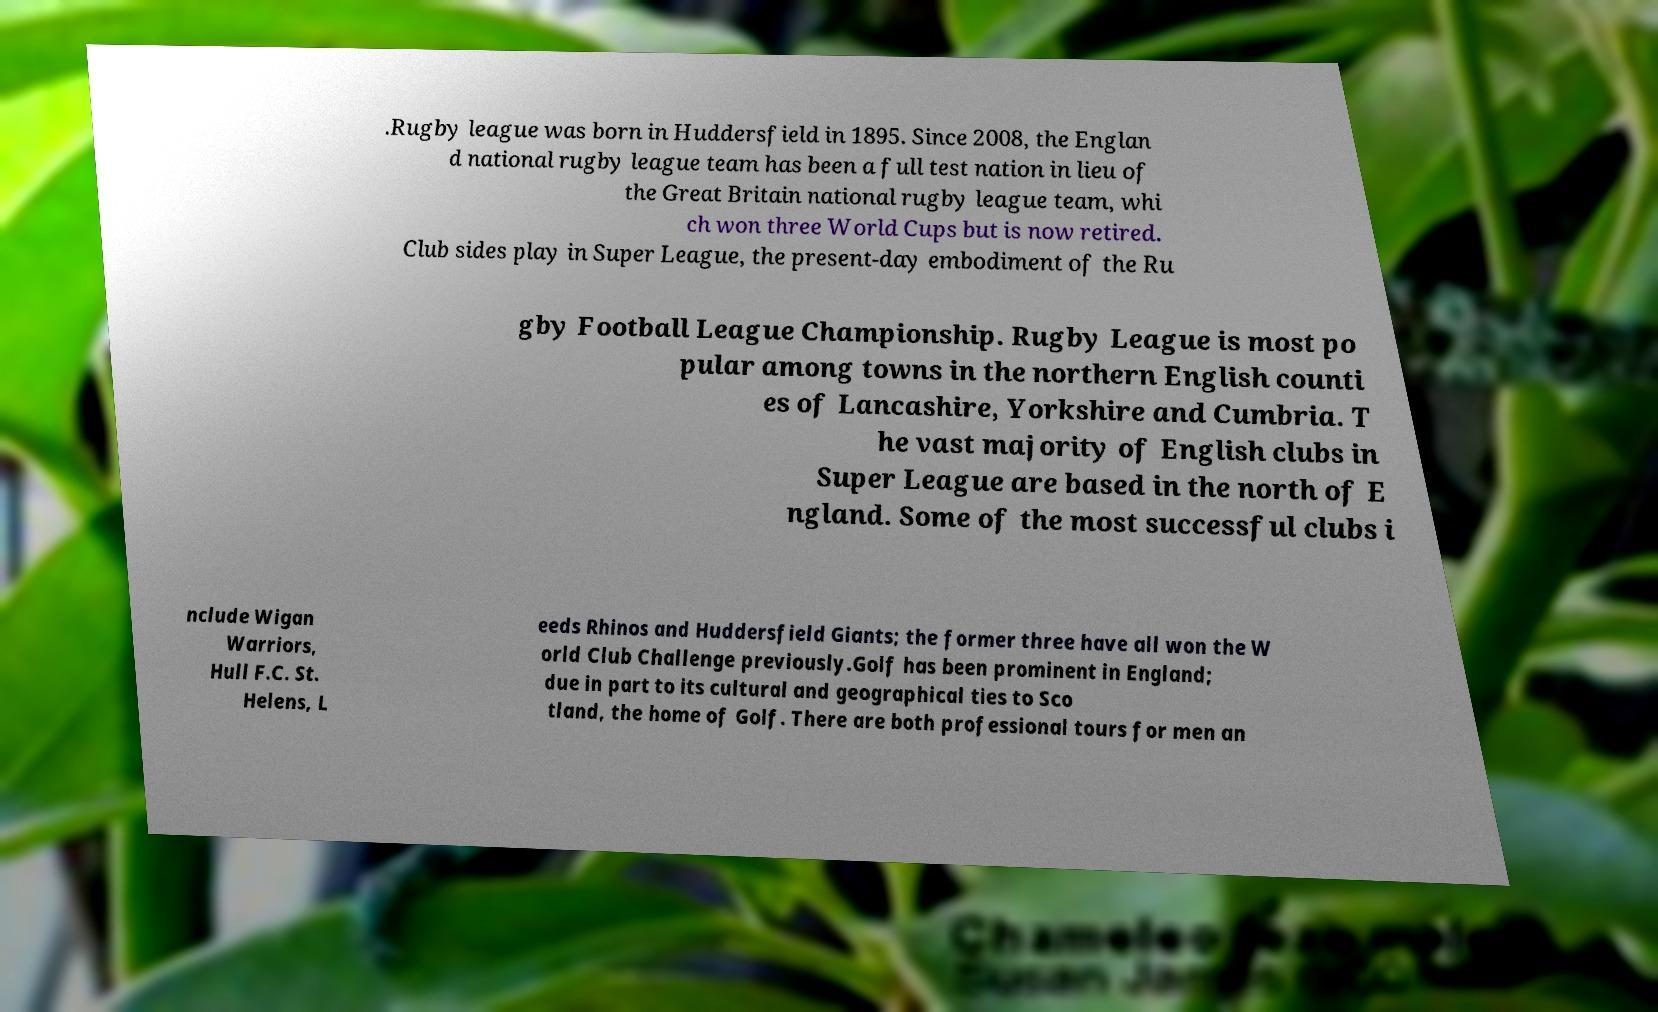For documentation purposes, I need the text within this image transcribed. Could you provide that? .Rugby league was born in Huddersfield in 1895. Since 2008, the Englan d national rugby league team has been a full test nation in lieu of the Great Britain national rugby league team, whi ch won three World Cups but is now retired. Club sides play in Super League, the present-day embodiment of the Ru gby Football League Championship. Rugby League is most po pular among towns in the northern English counti es of Lancashire, Yorkshire and Cumbria. T he vast majority of English clubs in Super League are based in the north of E ngland. Some of the most successful clubs i nclude Wigan Warriors, Hull F.C. St. Helens, L eeds Rhinos and Huddersfield Giants; the former three have all won the W orld Club Challenge previously.Golf has been prominent in England; due in part to its cultural and geographical ties to Sco tland, the home of Golf. There are both professional tours for men an 